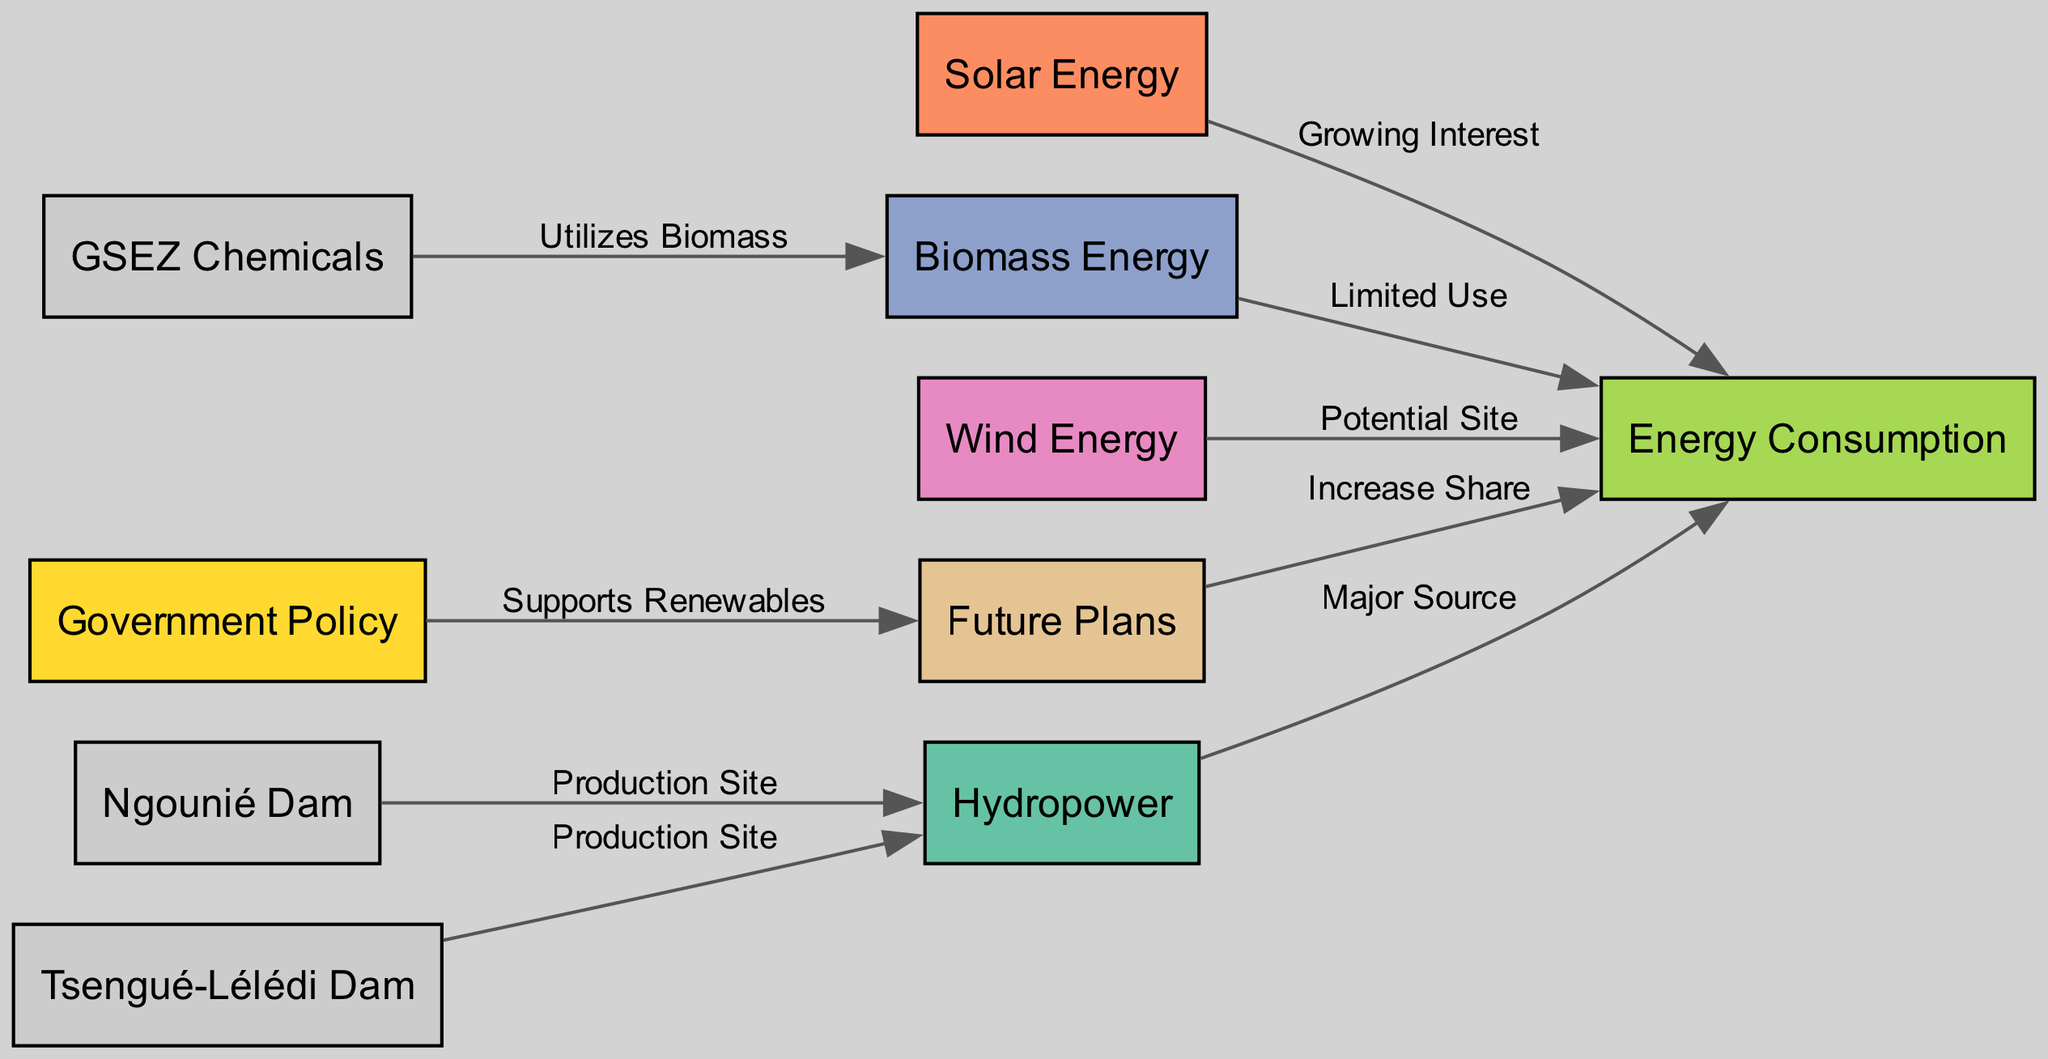What is the major source of energy consumption in Gabon? The diagram shows that hydropower is the major source of energy consumption as indicated by the edge connecting "hydropower" to "energy consumption," labeled as "Major Source."
Answer: Hydropower How many renewable energy sources are represented in the diagram? By counting the nodes related to renewable energy sources, we identify four: hydropower, solar energy, biomass energy, and wind energy.
Answer: Four What role does government policy play in future plans related to renewable energy? The diagram connects "government policy" to "future plans," labeled as "Supports Renewables," indicating that government policy plays a supportive role in the future planning of renewable energy.
Answer: Supports Renewables Which production sites contribute to hydropower? The diagram indicates that there are two production sites for hydropower: the Ngounié Dam and the Tsengué-Lélédi Dam, as shown by the edges connecting each dam to hydropower.
Answer: Ngounié Dam, Tsengué-Lélédi Dam What type of energy has a limited use according to the diagram? The edge from biomass energy to energy consumption indicates "Limited Use," which explicitly states that biomass energy is used to a limited extent.
Answer: Limited Use How does GSEZ Chemicals relate to biomass energy? According to the diagram, GSEZ Chemicals utilizes biomass energy, as shown by the edge connecting "gsezChemicals" to "biomassEnergy," labeled as "Utilizes Biomass."
Answer: Utilizes Biomass What is the anticipated change in energy consumption due to future plans? The diagram indicates that future plans aim to increase the share of energy consumption, as shown by the edge connecting "future plans" to "energy consumption," labeled as "Increase Share."
Answer: Increase Share Which renewable energy source is indicated to have a growing interest? The diagram shows that solar energy has a growing interest, indicated by the edge from "solarEnergy" to "energyConsumption," labeled as "Growing Interest."
Answer: Growing Interest 